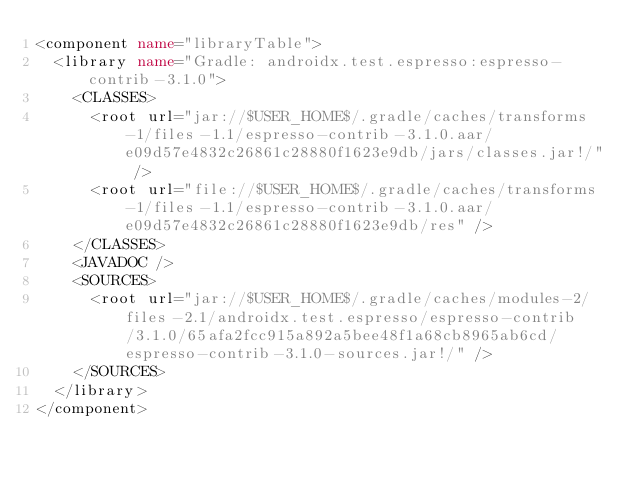<code> <loc_0><loc_0><loc_500><loc_500><_XML_><component name="libraryTable">
  <library name="Gradle: androidx.test.espresso:espresso-contrib-3.1.0">
    <CLASSES>
      <root url="jar://$USER_HOME$/.gradle/caches/transforms-1/files-1.1/espresso-contrib-3.1.0.aar/e09d57e4832c26861c28880f1623e9db/jars/classes.jar!/" />
      <root url="file://$USER_HOME$/.gradle/caches/transforms-1/files-1.1/espresso-contrib-3.1.0.aar/e09d57e4832c26861c28880f1623e9db/res" />
    </CLASSES>
    <JAVADOC />
    <SOURCES>
      <root url="jar://$USER_HOME$/.gradle/caches/modules-2/files-2.1/androidx.test.espresso/espresso-contrib/3.1.0/65afa2fcc915a892a5bee48f1a68cb8965ab6cd/espresso-contrib-3.1.0-sources.jar!/" />
    </SOURCES>
  </library>
</component></code> 